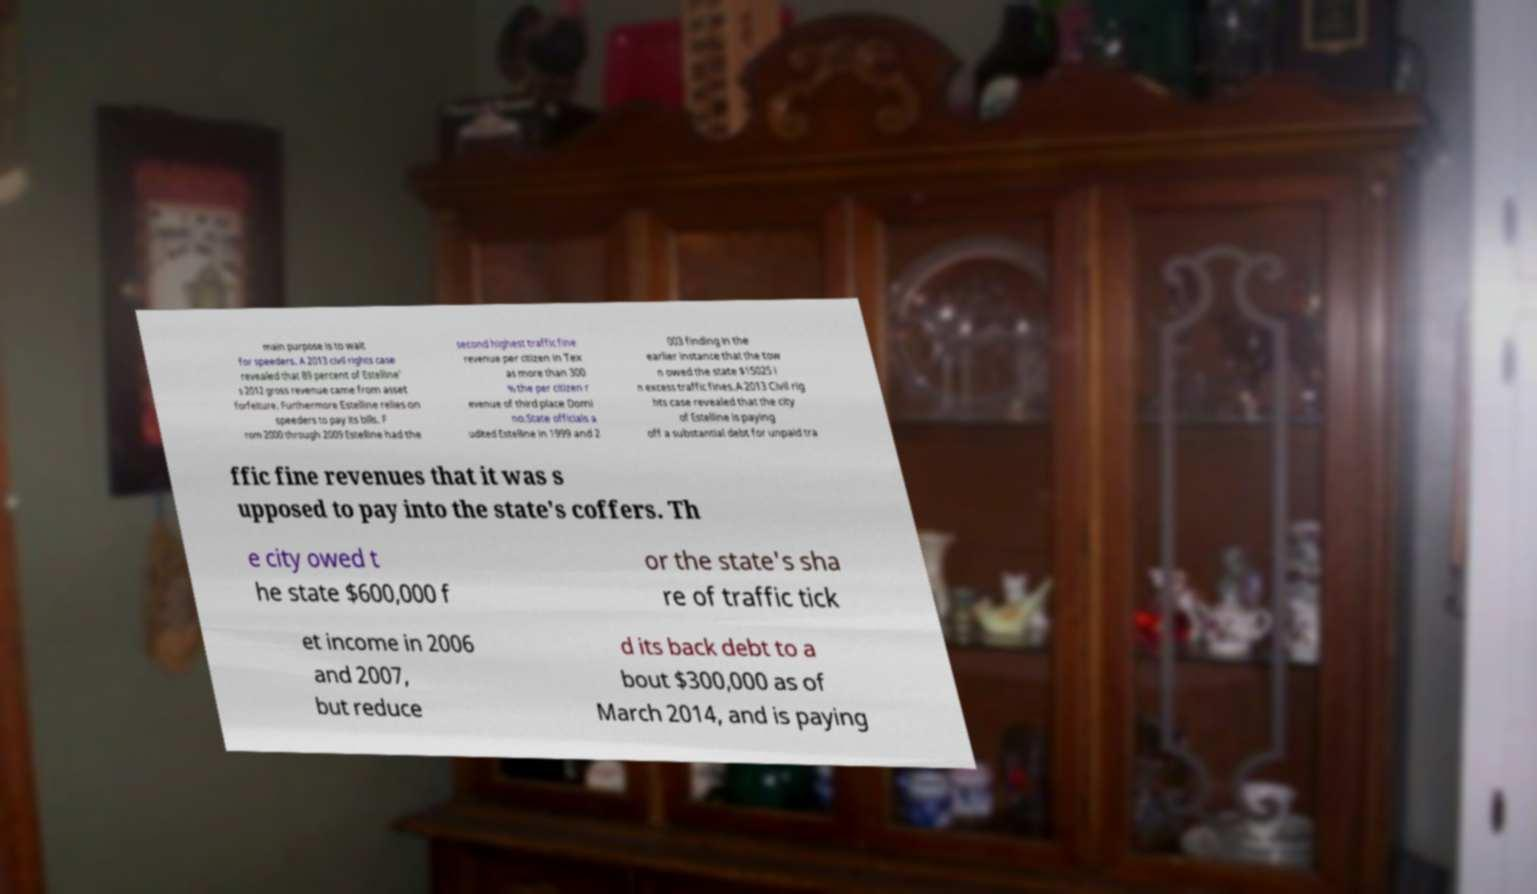Can you read and provide the text displayed in the image?This photo seems to have some interesting text. Can you extract and type it out for me? main purpose is to wait for speeders. A 2013 civil rights case revealed that 89 percent of Estelline' s 2012 gross revenue came from asset forfeiture. Furthermore Estelline relies on speeders to pay its bills. F rom 2000 through 2009 Estelline had the second highest traffic fine revenue per citizen in Tex as more than 300 % the per citizen r evenue of third place Domi no.State officials a udited Estelline in 1999 and 2 003 finding in the earlier instance that the tow n owed the state $15025 i n excess traffic fines.A 2013 Civil rig hts case revealed that the city of Estelline is paying off a substantial debt for unpaid tra ffic fine revenues that it was s upposed to pay into the state's coffers. Th e city owed t he state $600,000 f or the state's sha re of traffic tick et income in 2006 and 2007, but reduce d its back debt to a bout $300,000 as of March 2014, and is paying 